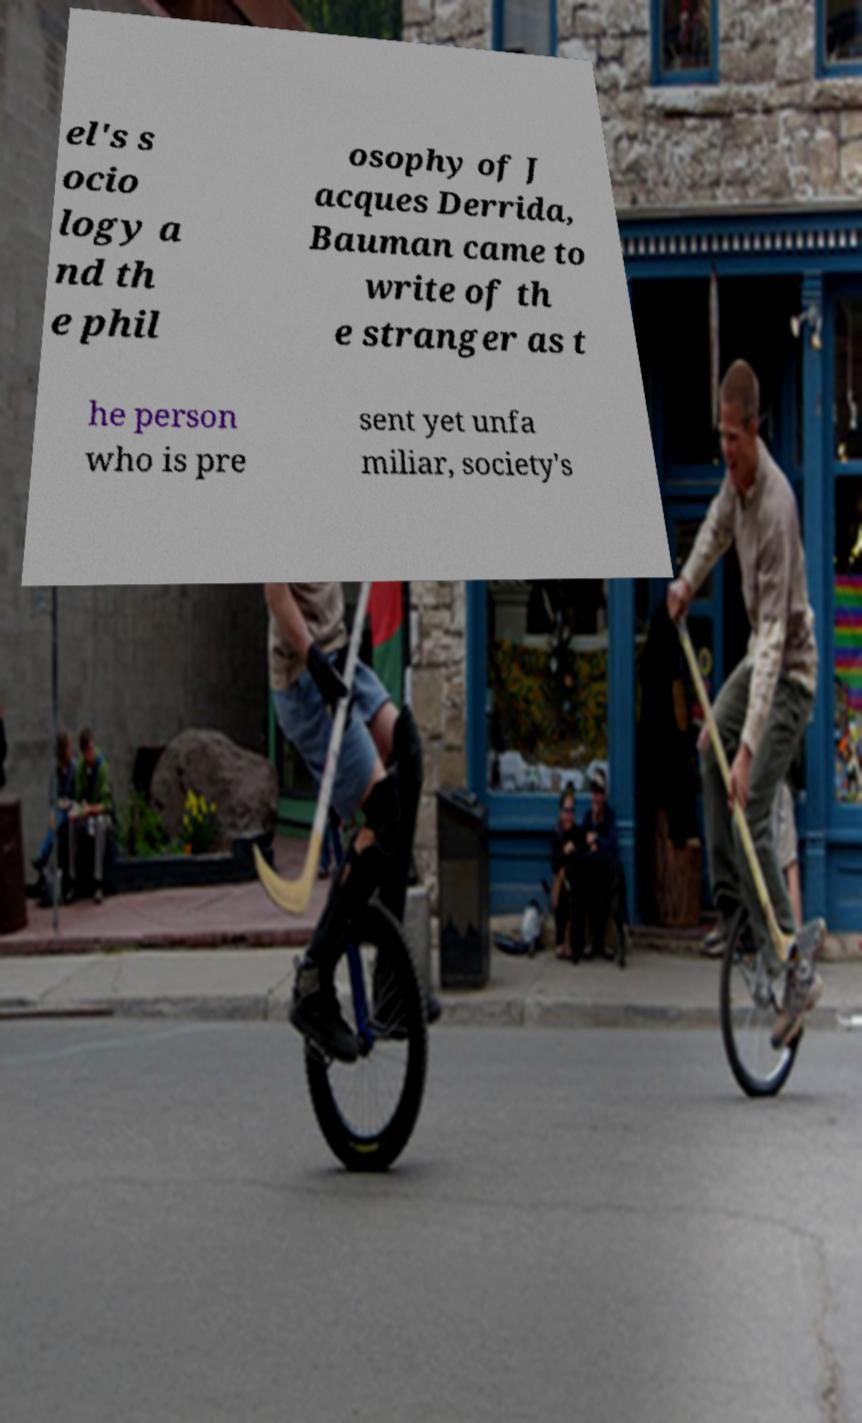I need the written content from this picture converted into text. Can you do that? el's s ocio logy a nd th e phil osophy of J acques Derrida, Bauman came to write of th e stranger as t he person who is pre sent yet unfa miliar, society's 